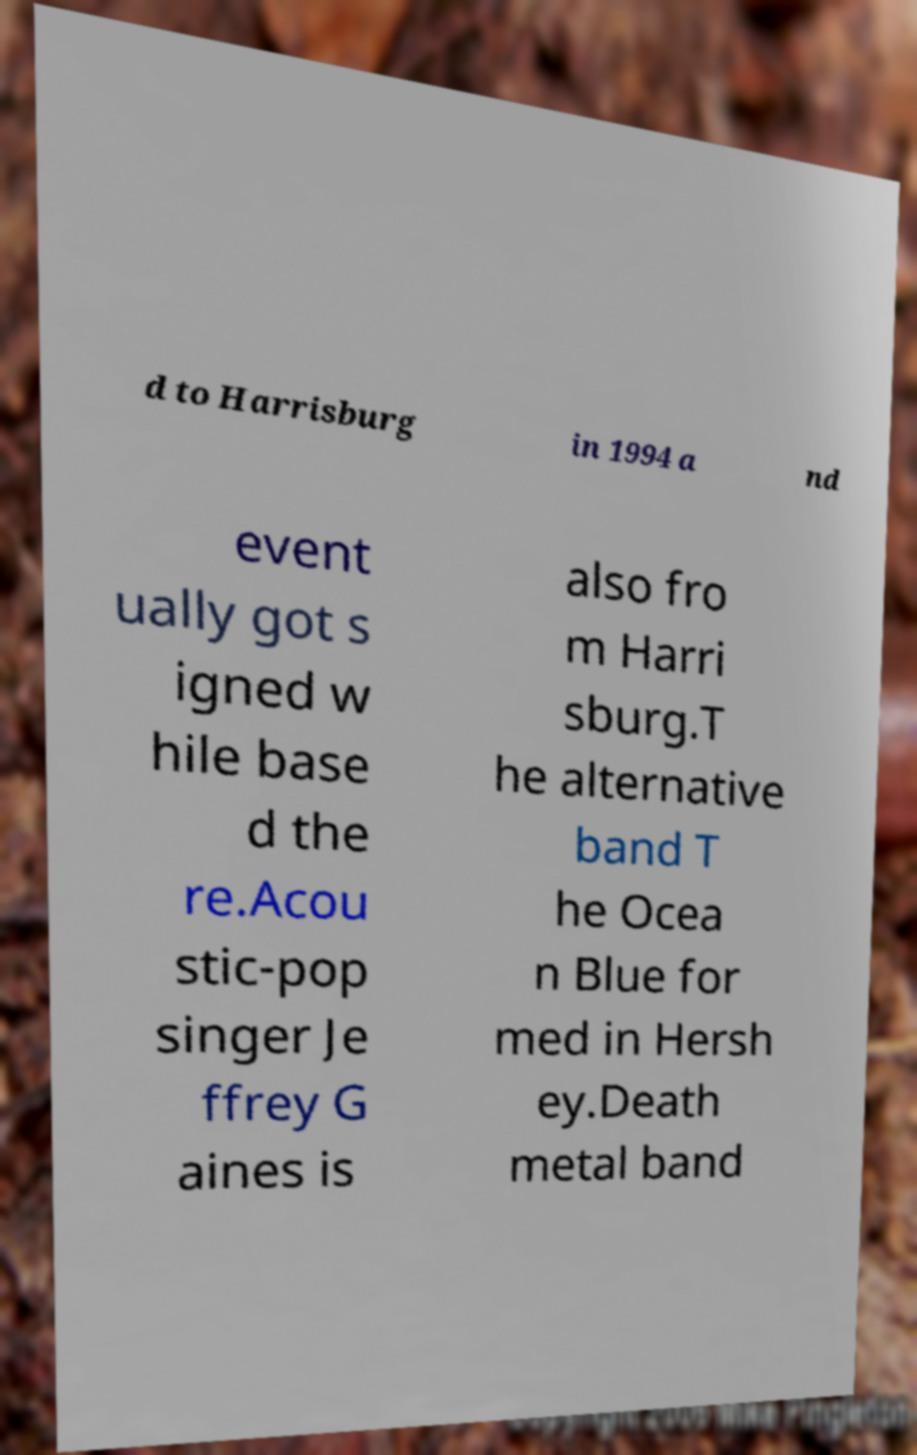I need the written content from this picture converted into text. Can you do that? d to Harrisburg in 1994 a nd event ually got s igned w hile base d the re.Acou stic-pop singer Je ffrey G aines is also fro m Harri sburg.T he alternative band T he Ocea n Blue for med in Hersh ey.Death metal band 